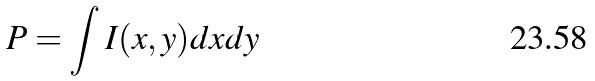Convert formula to latex. <formula><loc_0><loc_0><loc_500><loc_500>P = \int I ( x , y ) d x d y</formula> 